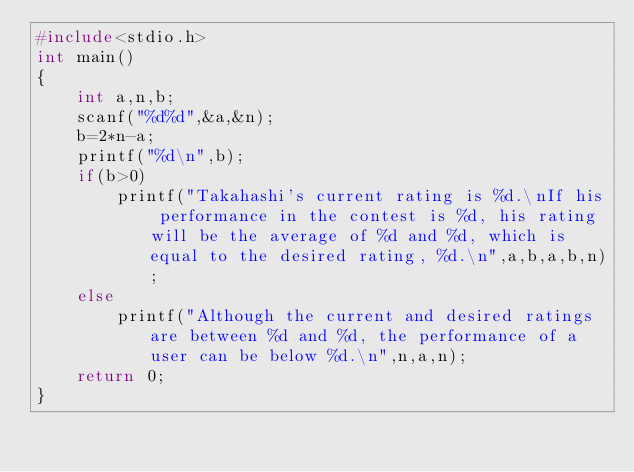<code> <loc_0><loc_0><loc_500><loc_500><_C_>#include<stdio.h>
int main()
{
    int a,n,b;
    scanf("%d%d",&a,&n);
    b=2*n-a;
    printf("%d\n",b);
    if(b>0)
        printf("Takahashi's current rating is %d.\nIf his performance in the contest is %d, his rating will be the average of %d and %d, which is equal to the desired rating, %d.\n",a,b,a,b,n);
    else
        printf("Although the current and desired ratings are between %d and %d, the performance of a user can be below %d.\n",n,a,n);
    return 0;
}
</code> 